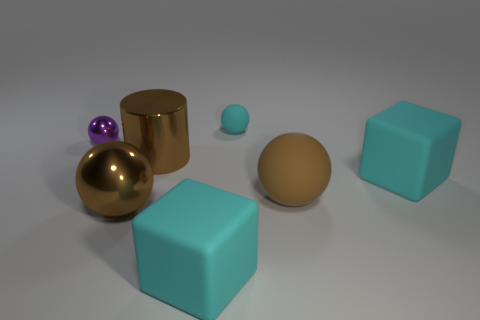What is the size of the cyan rubber block in front of the block to the right of the brown rubber ball?
Your answer should be compact. Large. There is a tiny thing that is to the right of the purple shiny sphere; is its color the same as the rubber sphere in front of the tiny purple shiny ball?
Make the answer very short. No. What number of small matte balls are behind the cyan cube behind the large brown ball on the right side of the shiny cylinder?
Your answer should be compact. 1. How many balls are on the left side of the small matte thing and in front of the small purple shiny sphere?
Make the answer very short. 1. Are there more rubber objects that are behind the small cyan rubber thing than big blocks?
Make the answer very short. No. How many cyan blocks have the same size as the brown matte thing?
Keep it short and to the point. 2. There is a cylinder that is the same color as the big matte sphere; what size is it?
Keep it short and to the point. Large. How many big objects are either brown shiny objects or shiny cylinders?
Keep it short and to the point. 2. What number of metal blocks are there?
Ensure brevity in your answer.  0. Are there an equal number of small cyan objects behind the small matte thing and tiny cyan spheres behind the brown rubber sphere?
Your answer should be compact. No. 